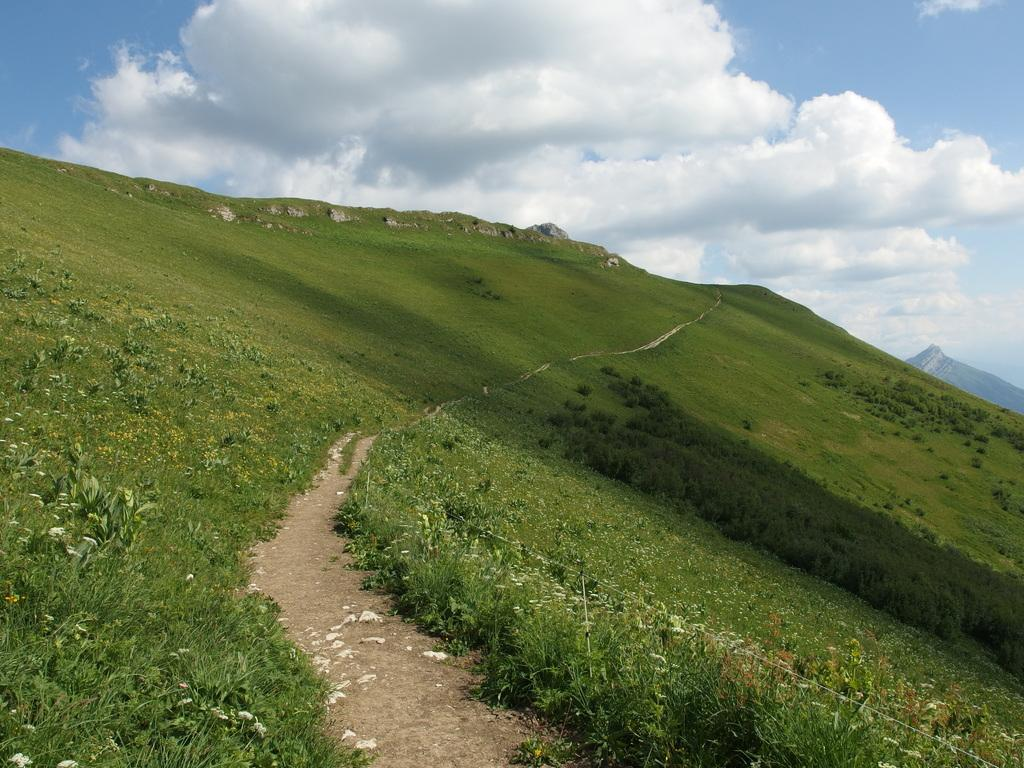What is the main feature in the middle of the image? There is a path in the middle of the image. What type of vegetation is present on either side of the path? There is grass on either side of the path. What can be seen at the bottom of the image? There are plants at the bottom of the image. What is visible at the top of the image? The sky is visible at the top of the image. Can you describe the sky in the image? The sky has clouds in it. What type of appliance can be seen playing in the band in the image? There is no appliance or band present in the image. Can you hear the people in the image laughing? The image is a still picture, so there is no sound or laughter present. 